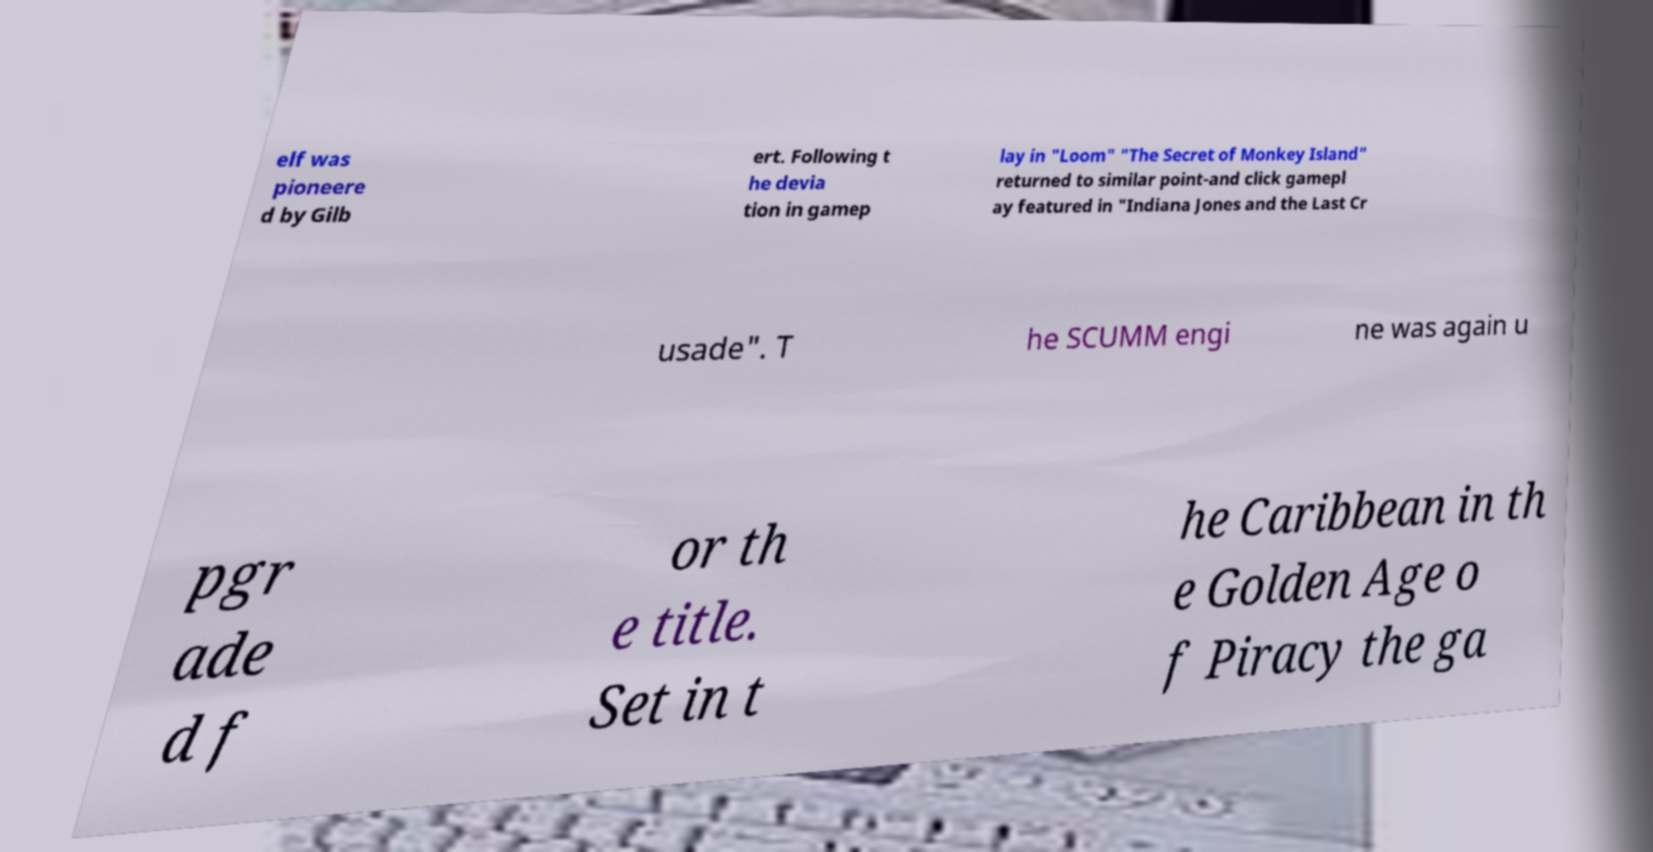I need the written content from this picture converted into text. Can you do that? elf was pioneere d by Gilb ert. Following t he devia tion in gamep lay in "Loom" "The Secret of Monkey Island" returned to similar point-and click gamepl ay featured in "Indiana Jones and the Last Cr usade". T he SCUMM engi ne was again u pgr ade d f or th e title. Set in t he Caribbean in th e Golden Age o f Piracy the ga 